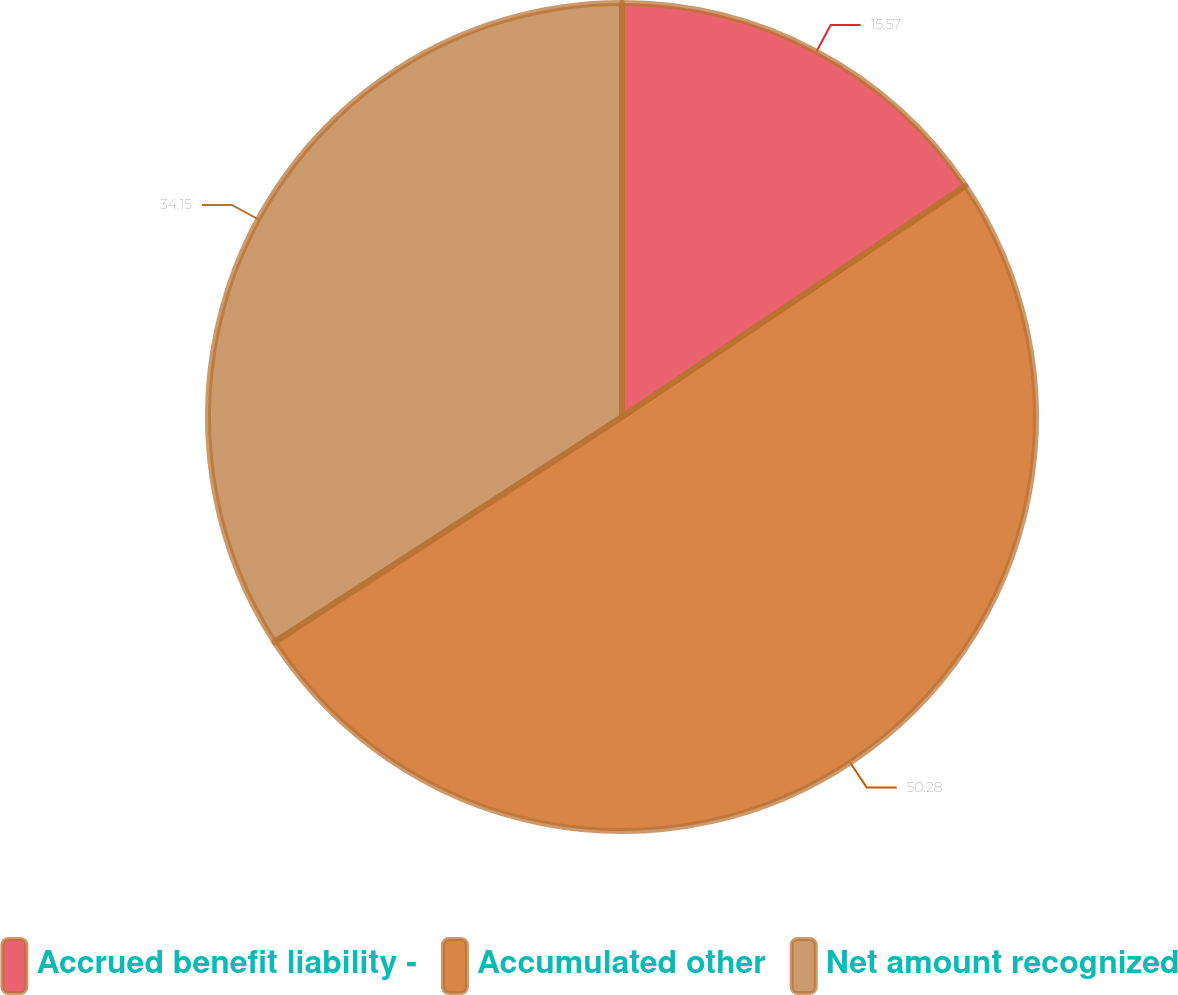Convert chart to OTSL. <chart><loc_0><loc_0><loc_500><loc_500><pie_chart><fcel>Accrued benefit liability -<fcel>Accumulated other<fcel>Net amount recognized<nl><fcel>15.57%<fcel>50.28%<fcel>34.15%<nl></chart> 